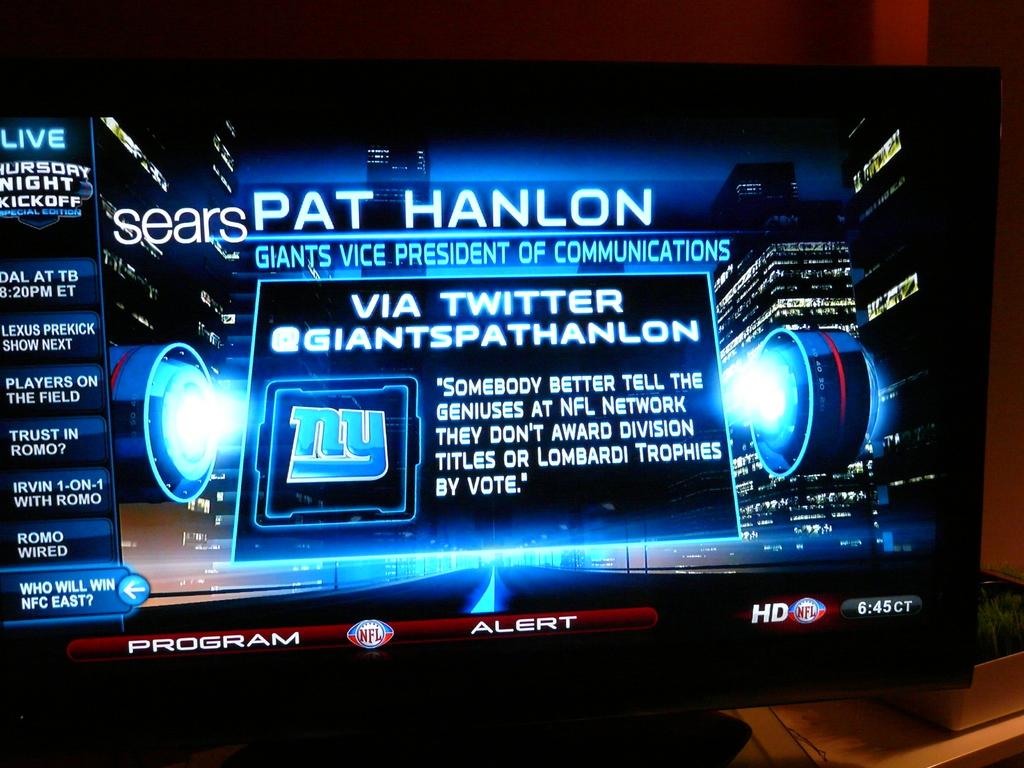Who is the giants vice president of communications?
Offer a very short reply. Pat hanlon. What social media is displayed?
Ensure brevity in your answer.  Twitter. 